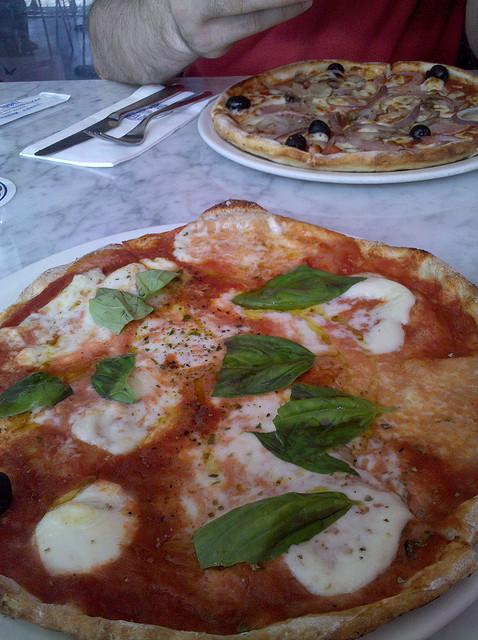Are these thin crust pizzas?
Write a very short answer. Yes. What are the round green items on this pizza?
Quick response, please. Basil. Are any slices gone out of either pizza?
Be succinct. No. Does the first pizza have parsley on it?
Quick response, please. Yes. What color is the table?
Quick response, please. White. IS there green leaves on the pizza?
Quick response, please. Yes. What is the table made out of?
Short answer required. Marble. What is the table made of?
Be succinct. Marble. What kind of pizza is the closest one?
Short answer required. Cheese. 